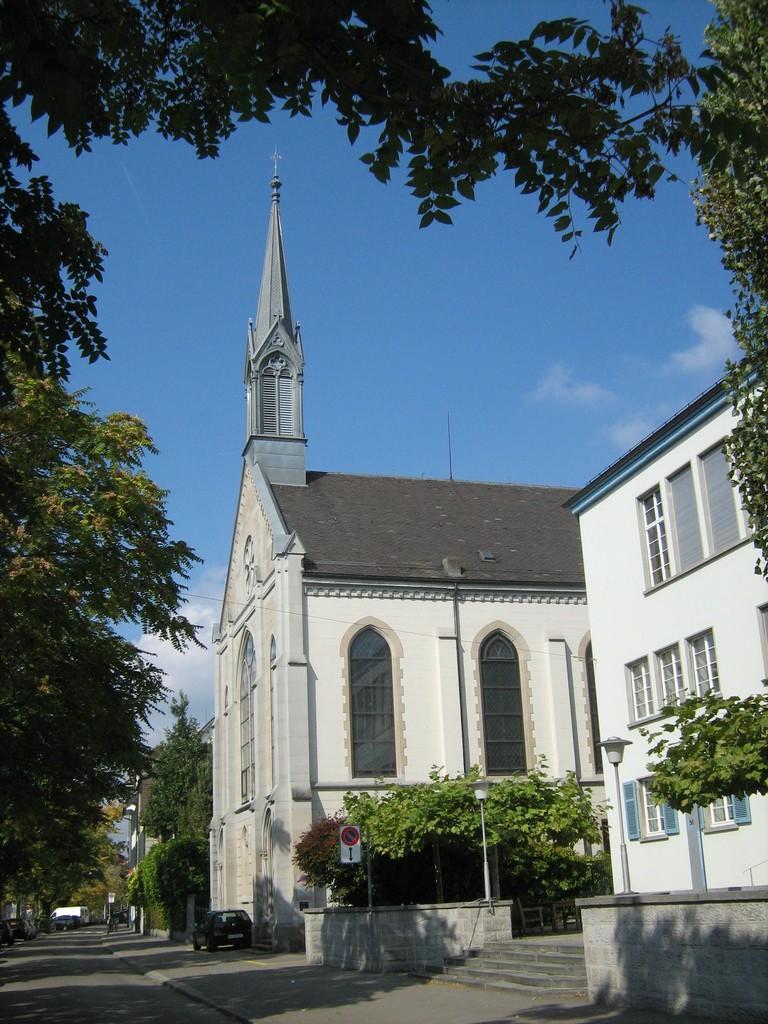Could you give a brief overview of what you see in this image? In this picture we can see the road, vehicle, signboard, light poles, trees, buildings with windows, some objects and in the background we can see the sky. 